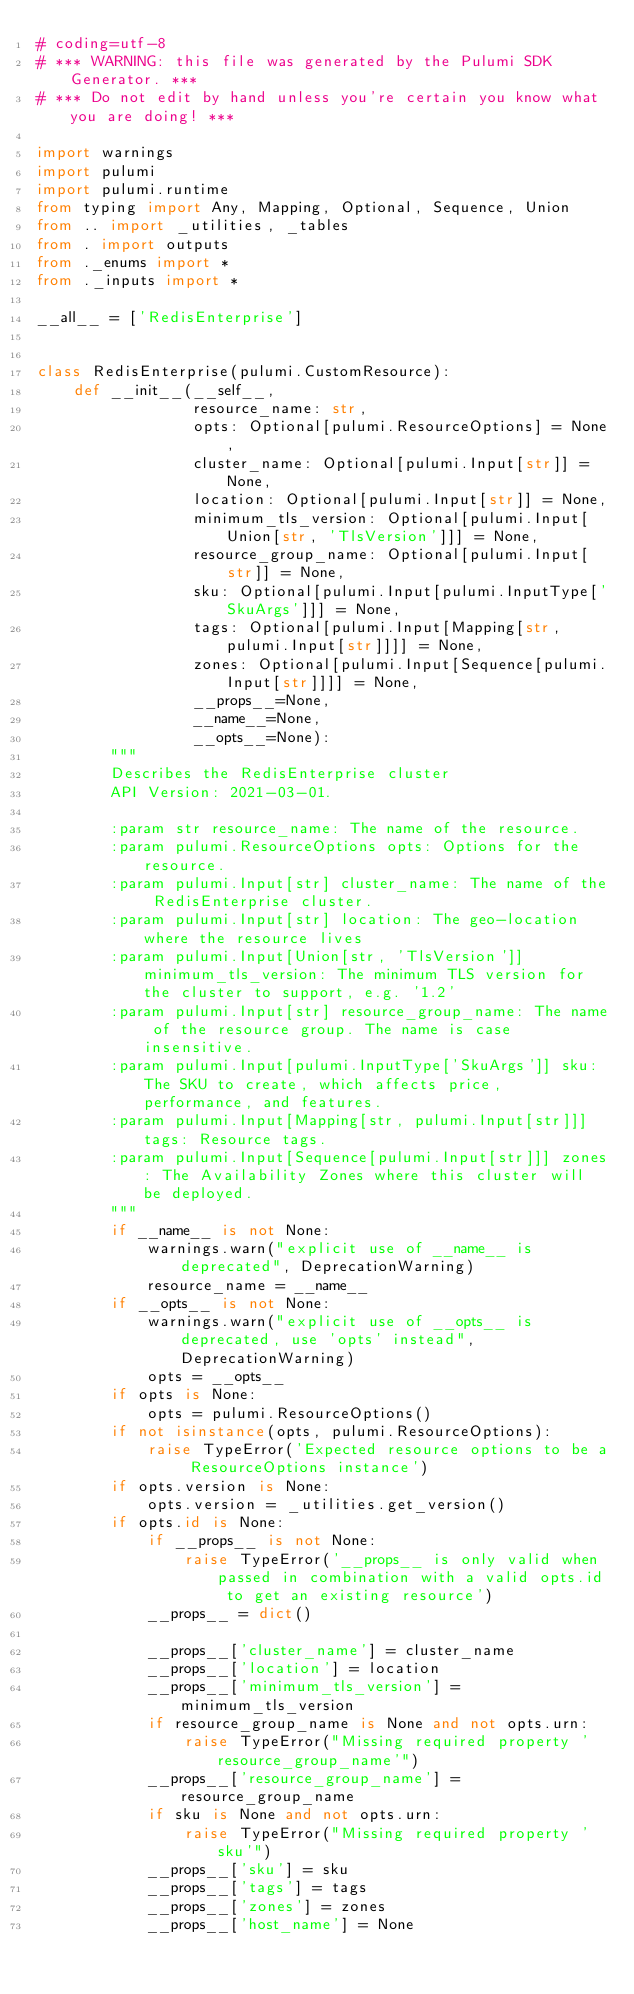Convert code to text. <code><loc_0><loc_0><loc_500><loc_500><_Python_># coding=utf-8
# *** WARNING: this file was generated by the Pulumi SDK Generator. ***
# *** Do not edit by hand unless you're certain you know what you are doing! ***

import warnings
import pulumi
import pulumi.runtime
from typing import Any, Mapping, Optional, Sequence, Union
from .. import _utilities, _tables
from . import outputs
from ._enums import *
from ._inputs import *

__all__ = ['RedisEnterprise']


class RedisEnterprise(pulumi.CustomResource):
    def __init__(__self__,
                 resource_name: str,
                 opts: Optional[pulumi.ResourceOptions] = None,
                 cluster_name: Optional[pulumi.Input[str]] = None,
                 location: Optional[pulumi.Input[str]] = None,
                 minimum_tls_version: Optional[pulumi.Input[Union[str, 'TlsVersion']]] = None,
                 resource_group_name: Optional[pulumi.Input[str]] = None,
                 sku: Optional[pulumi.Input[pulumi.InputType['SkuArgs']]] = None,
                 tags: Optional[pulumi.Input[Mapping[str, pulumi.Input[str]]]] = None,
                 zones: Optional[pulumi.Input[Sequence[pulumi.Input[str]]]] = None,
                 __props__=None,
                 __name__=None,
                 __opts__=None):
        """
        Describes the RedisEnterprise cluster
        API Version: 2021-03-01.

        :param str resource_name: The name of the resource.
        :param pulumi.ResourceOptions opts: Options for the resource.
        :param pulumi.Input[str] cluster_name: The name of the RedisEnterprise cluster.
        :param pulumi.Input[str] location: The geo-location where the resource lives
        :param pulumi.Input[Union[str, 'TlsVersion']] minimum_tls_version: The minimum TLS version for the cluster to support, e.g. '1.2'
        :param pulumi.Input[str] resource_group_name: The name of the resource group. The name is case insensitive.
        :param pulumi.Input[pulumi.InputType['SkuArgs']] sku: The SKU to create, which affects price, performance, and features.
        :param pulumi.Input[Mapping[str, pulumi.Input[str]]] tags: Resource tags.
        :param pulumi.Input[Sequence[pulumi.Input[str]]] zones: The Availability Zones where this cluster will be deployed.
        """
        if __name__ is not None:
            warnings.warn("explicit use of __name__ is deprecated", DeprecationWarning)
            resource_name = __name__
        if __opts__ is not None:
            warnings.warn("explicit use of __opts__ is deprecated, use 'opts' instead", DeprecationWarning)
            opts = __opts__
        if opts is None:
            opts = pulumi.ResourceOptions()
        if not isinstance(opts, pulumi.ResourceOptions):
            raise TypeError('Expected resource options to be a ResourceOptions instance')
        if opts.version is None:
            opts.version = _utilities.get_version()
        if opts.id is None:
            if __props__ is not None:
                raise TypeError('__props__ is only valid when passed in combination with a valid opts.id to get an existing resource')
            __props__ = dict()

            __props__['cluster_name'] = cluster_name
            __props__['location'] = location
            __props__['minimum_tls_version'] = minimum_tls_version
            if resource_group_name is None and not opts.urn:
                raise TypeError("Missing required property 'resource_group_name'")
            __props__['resource_group_name'] = resource_group_name
            if sku is None and not opts.urn:
                raise TypeError("Missing required property 'sku'")
            __props__['sku'] = sku
            __props__['tags'] = tags
            __props__['zones'] = zones
            __props__['host_name'] = None</code> 